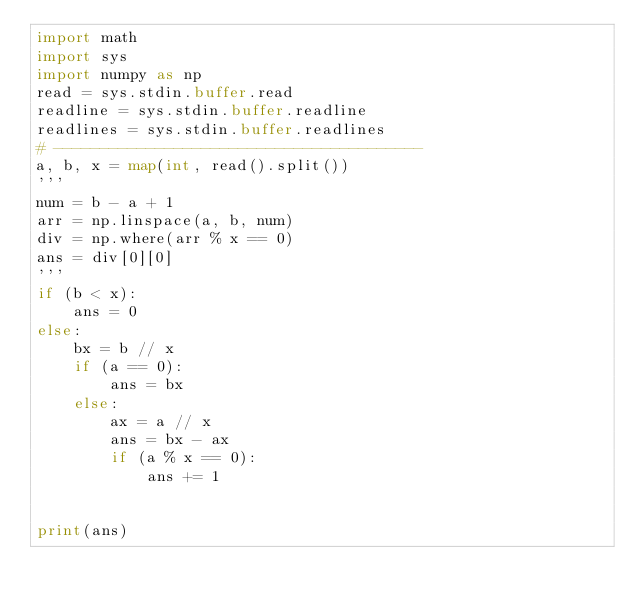Convert code to text. <code><loc_0><loc_0><loc_500><loc_500><_Python_>import math
import sys
import numpy as np
read = sys.stdin.buffer.read
readline = sys.stdin.buffer.readline
readlines = sys.stdin.buffer.readlines
# ----------------------------------------
a, b, x = map(int, read().split())
'''
num = b - a + 1
arr = np.linspace(a, b, num)
div = np.where(arr % x == 0)
ans = div[0][0]
'''
if (b < x):
    ans = 0
else:
    bx = b // x
    if (a == 0):
        ans = bx
    else:
        ax = a // x
        ans = bx - ax
        if (a % x == 0):
            ans += 1


print(ans)
</code> 